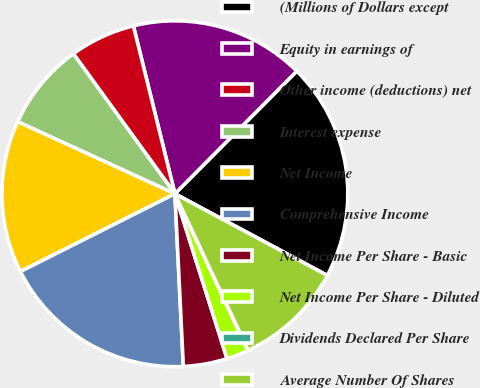Convert chart to OTSL. <chart><loc_0><loc_0><loc_500><loc_500><pie_chart><fcel>(Millions of Dollars except<fcel>Equity in earnings of<fcel>Other income (deductions) net<fcel>Interest expense<fcel>Net Income<fcel>Comprehensive Income<fcel>Net Income Per Share - Basic<fcel>Net Income Per Share - Diluted<fcel>Dividends Declared Per Share<fcel>Average Number Of Shares<nl><fcel>20.38%<fcel>16.31%<fcel>6.13%<fcel>8.17%<fcel>14.27%<fcel>18.35%<fcel>4.1%<fcel>2.06%<fcel>0.03%<fcel>10.2%<nl></chart> 